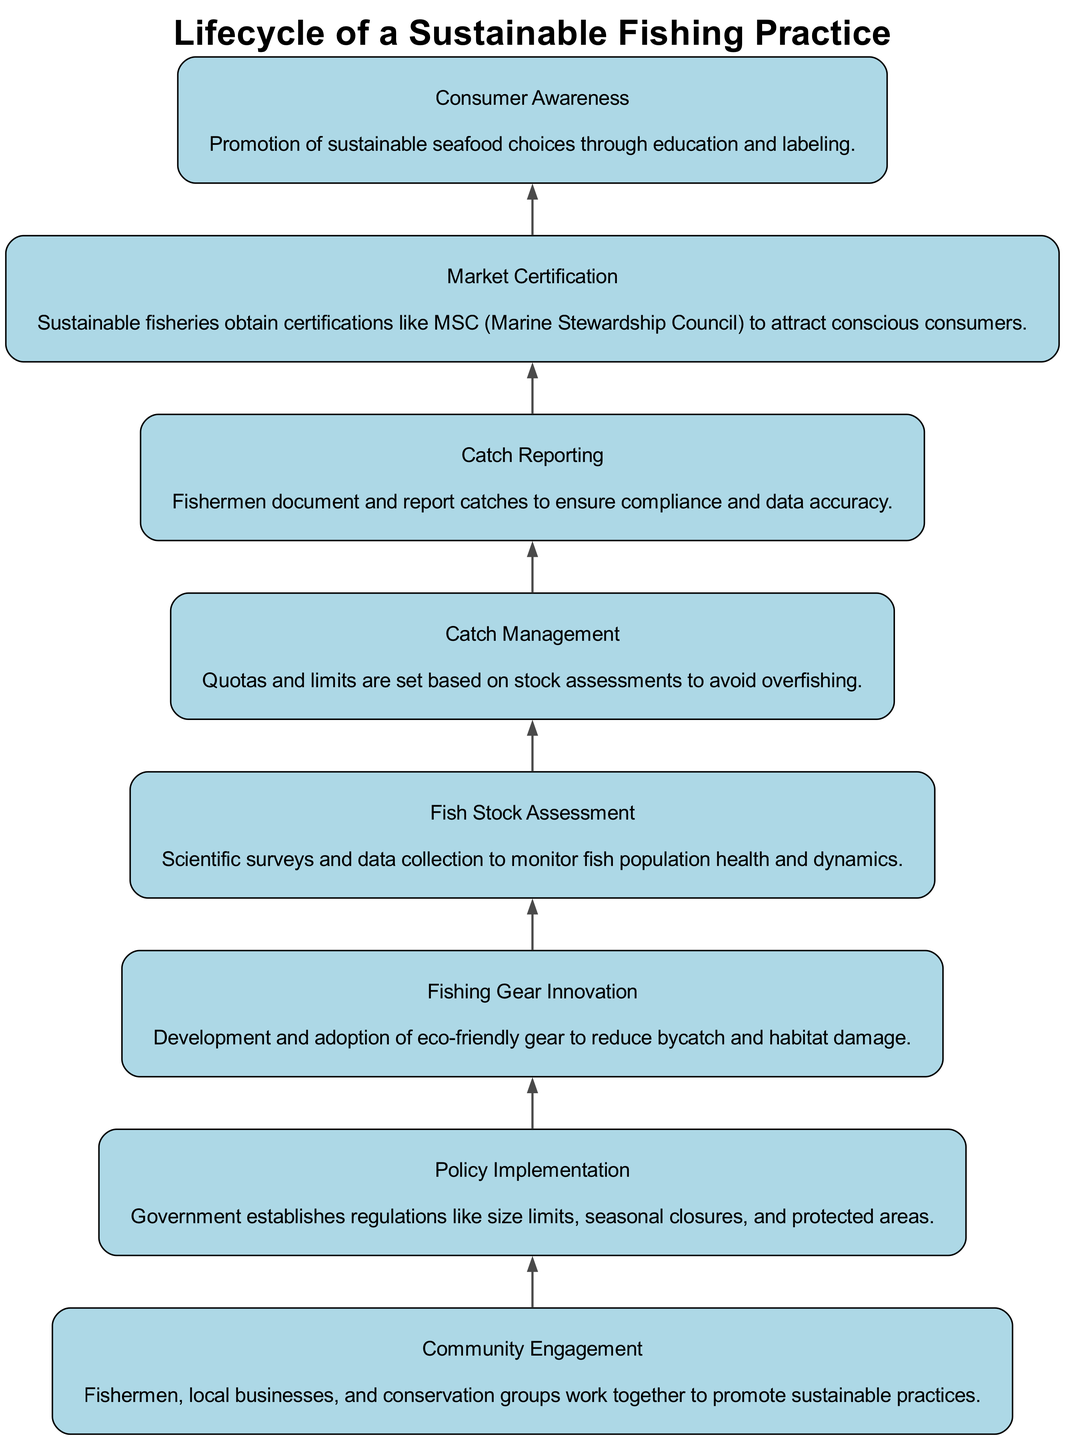What is the first step in the lifecycle? The bottom node in the diagram represents the first step, which is "Community Engagement."
Answer: Community Engagement How many main elements are there in the diagram? Count the nodes in the diagram. There are eight elements listed in total, which can be identified from their unique descriptions.
Answer: 8 What is the final step in the flowchart? The topmost node signifies the last step in the process, which is "Consumer Awareness."
Answer: Consumer Awareness Which step comes directly after "Fish Stock Assessment"? By tracing the flow from "Fish Stock Assessment," the next node in the upward direction is "Catch Management."
Answer: Catch Management What regulates the fishing practices to ensure sustainability? "Policy Implementation" is the step where regulations like size limits, seasonal closures, and protected areas are established to promote sustainable fishing.
Answer: Policy Implementation Which step involves fishermen documenting their catches? The node that discusses the action of fishermen reporting their catches is labeled "Catch Reporting."
Answer: Catch Reporting What does "Market Certification" aim to do? The description for "Market Certification" states that it is aimed at attracting conscious consumers through sustainable fisheries certifications.
Answer: Attract conscious consumers What are fishermen required to do to ensure compliance and data accuracy? The process where fishermen document their catches is referred to as "Catch Reporting."
Answer: Catch Reporting Which two steps focus on educating consumers about sustainable seafood? The relevant steps include "Consumer Awareness" and "Market Certification," as both are linked to promoting sustainable seafood choices through education and labeling.
Answer: Consumer Awareness and Market Certification 